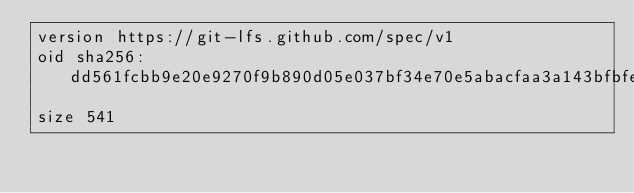<code> <loc_0><loc_0><loc_500><loc_500><_SQL_>version https://git-lfs.github.com/spec/v1
oid sha256:dd561fcbb9e20e9270f9b890d05e037bf34e70e5abacfaa3a143bfbfea2f5ec8
size 541
</code> 